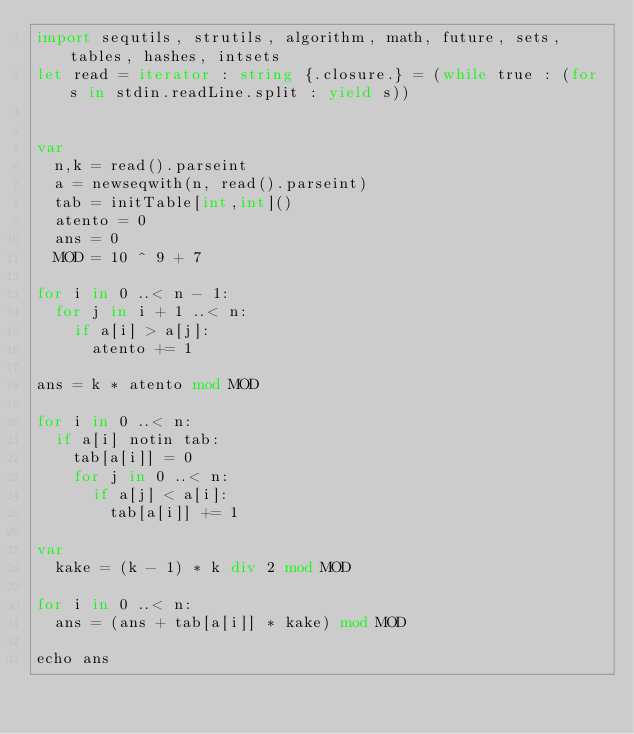Convert code to text. <code><loc_0><loc_0><loc_500><loc_500><_Nim_>import sequtils, strutils, algorithm, math, future, sets, tables, hashes, intsets
let read = iterator : string {.closure.} = (while true : (for s in stdin.readLine.split : yield s))


var
  n,k = read().parseint
  a = newseqwith(n, read().parseint)
  tab = initTable[int,int]()
  atento = 0
  ans = 0
  MOD = 10 ^ 9 + 7

for i in 0 ..< n - 1:
  for j in i + 1 ..< n:
    if a[i] > a[j]:
      atento += 1

ans = k * atento mod MOD

for i in 0 ..< n:
  if a[i] notin tab:
    tab[a[i]] = 0
    for j in 0 ..< n:
      if a[j] < a[i]:
        tab[a[i]] += 1

var
  kake = (k - 1) * k div 2 mod MOD

for i in 0 ..< n:
  ans = (ans + tab[a[i]] * kake) mod MOD

echo ans



</code> 